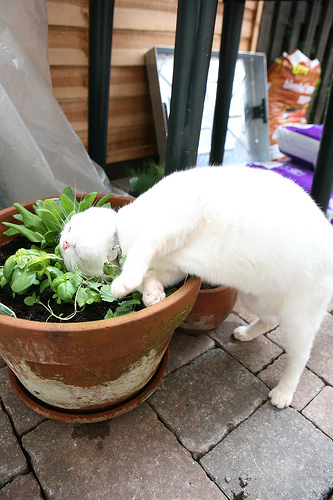Do you see a pot in this photo? Yes, there is a pot visible in the photo. 